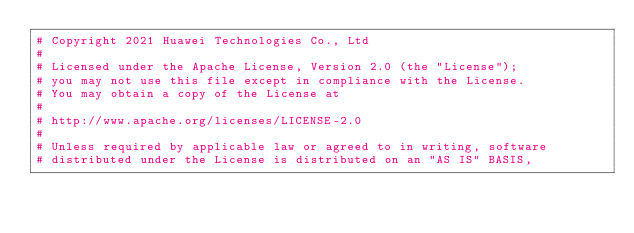<code> <loc_0><loc_0><loc_500><loc_500><_Python_># Copyright 2021 Huawei Technologies Co., Ltd
#
# Licensed under the Apache License, Version 2.0 (the "License");
# you may not use this file except in compliance with the License.
# You may obtain a copy of the License at
#
# http://www.apache.org/licenses/LICENSE-2.0
#
# Unless required by applicable law or agreed to in writing, software
# distributed under the License is distributed on an "AS IS" BASIS,</code> 